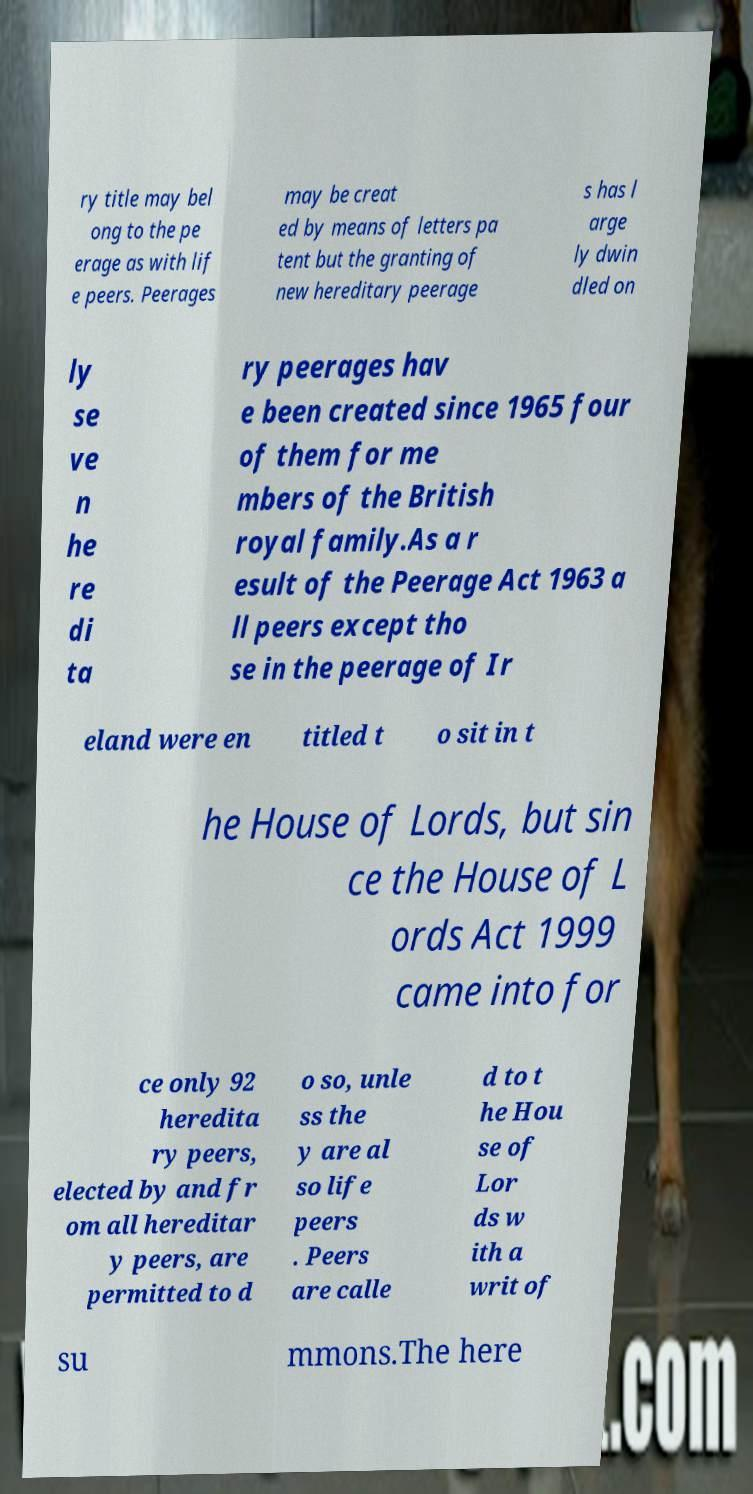Please identify and transcribe the text found in this image. ry title may bel ong to the pe erage as with lif e peers. Peerages may be creat ed by means of letters pa tent but the granting of new hereditary peerage s has l arge ly dwin dled on ly se ve n he re di ta ry peerages hav e been created since 1965 four of them for me mbers of the British royal family.As a r esult of the Peerage Act 1963 a ll peers except tho se in the peerage of Ir eland were en titled t o sit in t he House of Lords, but sin ce the House of L ords Act 1999 came into for ce only 92 heredita ry peers, elected by and fr om all hereditar y peers, are permitted to d o so, unle ss the y are al so life peers . Peers are calle d to t he Hou se of Lor ds w ith a writ of su mmons.The here 